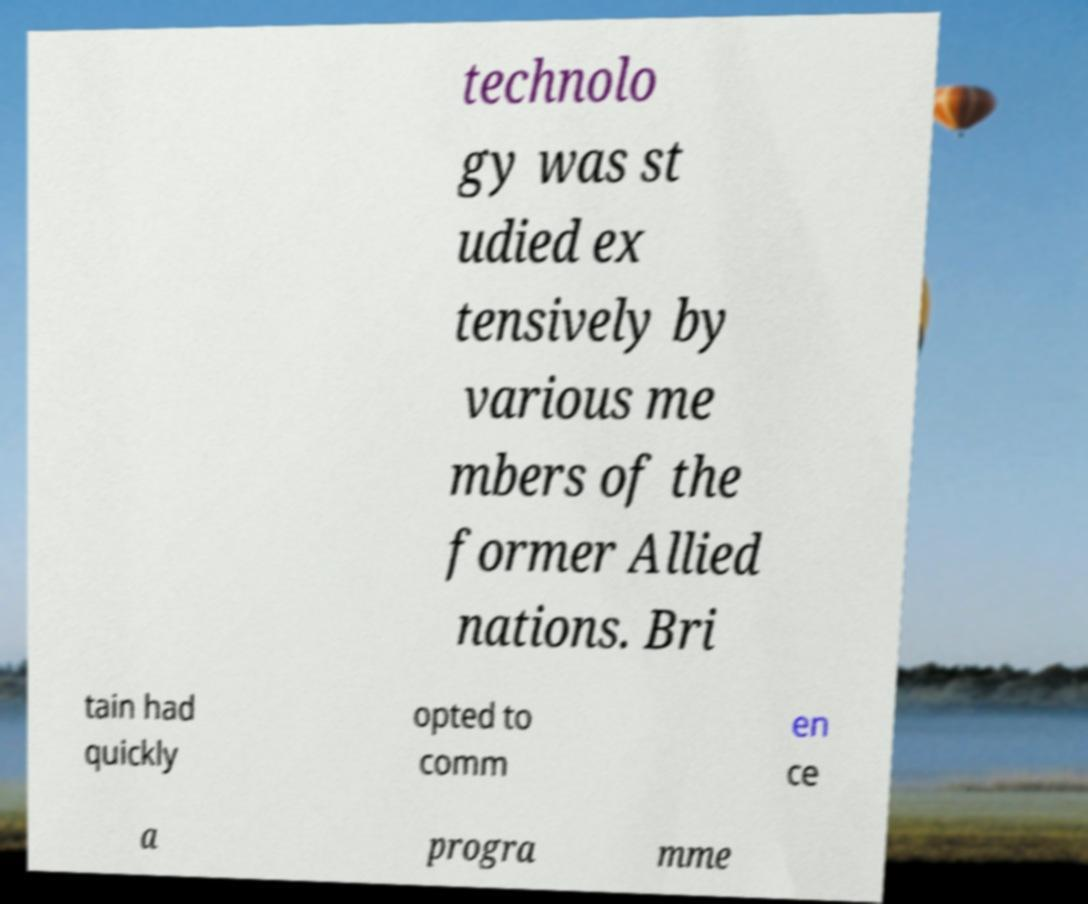Could you extract and type out the text from this image? technolo gy was st udied ex tensively by various me mbers of the former Allied nations. Bri tain had quickly opted to comm en ce a progra mme 